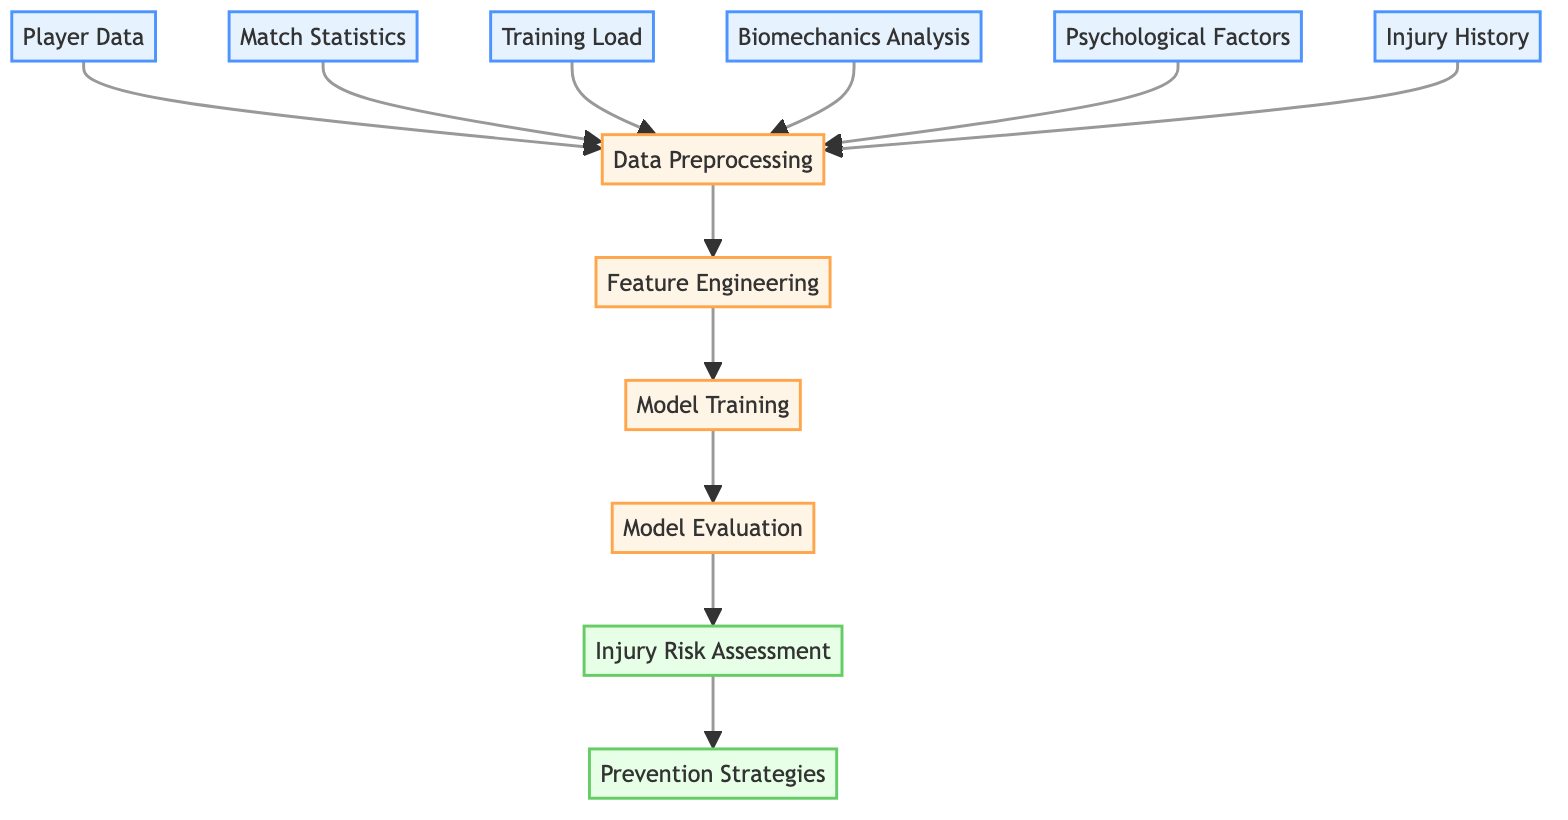What are the inputs to the data preprocessing node? The data preprocessing node receives input from six different nodes, which are player data, match statistics, training load, biomechanics analysis, psychological factors, and injury history.
Answer: Player data, match statistics, training load, biomechanics analysis, psychological factors, injury history How many nodes are in the diagram? The diagram includes a total of 11 nodes, consisting of both input nodes and process/output nodes.
Answer: 11 What is the output of the model evaluation node? The model evaluation node outputs to the injury risk assessment node, representing the evaluation of the trained model's performance.
Answer: Injury risk assessment Which node is bolded in the diagram? Three nodes are bolded in the diagram, specifically data preprocessing, model training, and injury risk assessment, which indicates their importance in the process flow.
Answer: Data preprocessing, model training, injury risk assessment What is the first step after data preprocessing? After data preprocessing, the next step is feature engineering, where the cleaned and structured data is transformed to be suitable for training a model.
Answer: Feature engineering What connects the model training node to the model evaluation node? The connection between the model training node and the model evaluation node represents the flow of information where the trained model is evaluated on how well it performs before assessing injury risk.
Answer: Model training to model evaluation How many output nodes are in the diagram? There are two output nodes in the diagram, which are injury risk assessment and prevention strategies, representing the final stages of the process.
Answer: 2 What does the injury risk assessment node lead to? The injury risk assessment node leads to the prevention strategies node, indicating that the assessment informs strategies aimed at preventing injuries.
Answer: Prevention strategies 